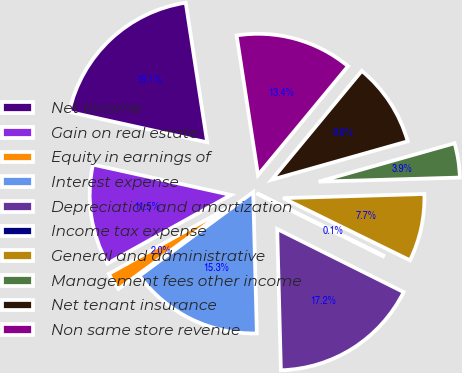Convert chart. <chart><loc_0><loc_0><loc_500><loc_500><pie_chart><fcel>Net Income<fcel>Gain on real estate<fcel>Equity in earnings of<fcel>Interest expense<fcel>Depreciation and amortization<fcel>Income tax expense<fcel>General and administrative<fcel>Management fees other income<fcel>Net tenant insurance<fcel>Non same store revenue<nl><fcel>19.13%<fcel>11.52%<fcel>2.02%<fcel>15.32%<fcel>17.22%<fcel>0.11%<fcel>7.72%<fcel>3.92%<fcel>9.62%<fcel>13.42%<nl></chart> 